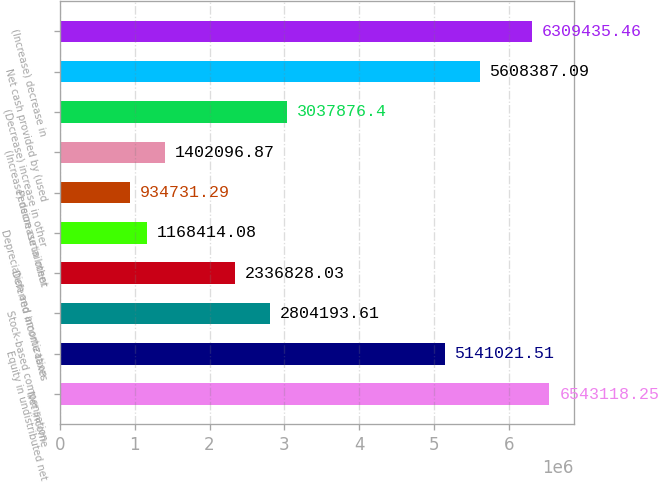<chart> <loc_0><loc_0><loc_500><loc_500><bar_chart><fcel>Net income<fcel>Equity in undistributed net<fcel>Stock-based compensation<fcel>Deferred income taxes<fcel>Depreciation and amortization<fcel>Pension curtailment<fcel>(Increase) decrease in other<fcel>(Decrease) increase in other<fcel>Net cash provided by (used<fcel>(Increase) decrease in<nl><fcel>6.54312e+06<fcel>5.14102e+06<fcel>2.80419e+06<fcel>2.33683e+06<fcel>1.16841e+06<fcel>934731<fcel>1.4021e+06<fcel>3.03788e+06<fcel>5.60839e+06<fcel>6.30944e+06<nl></chart> 